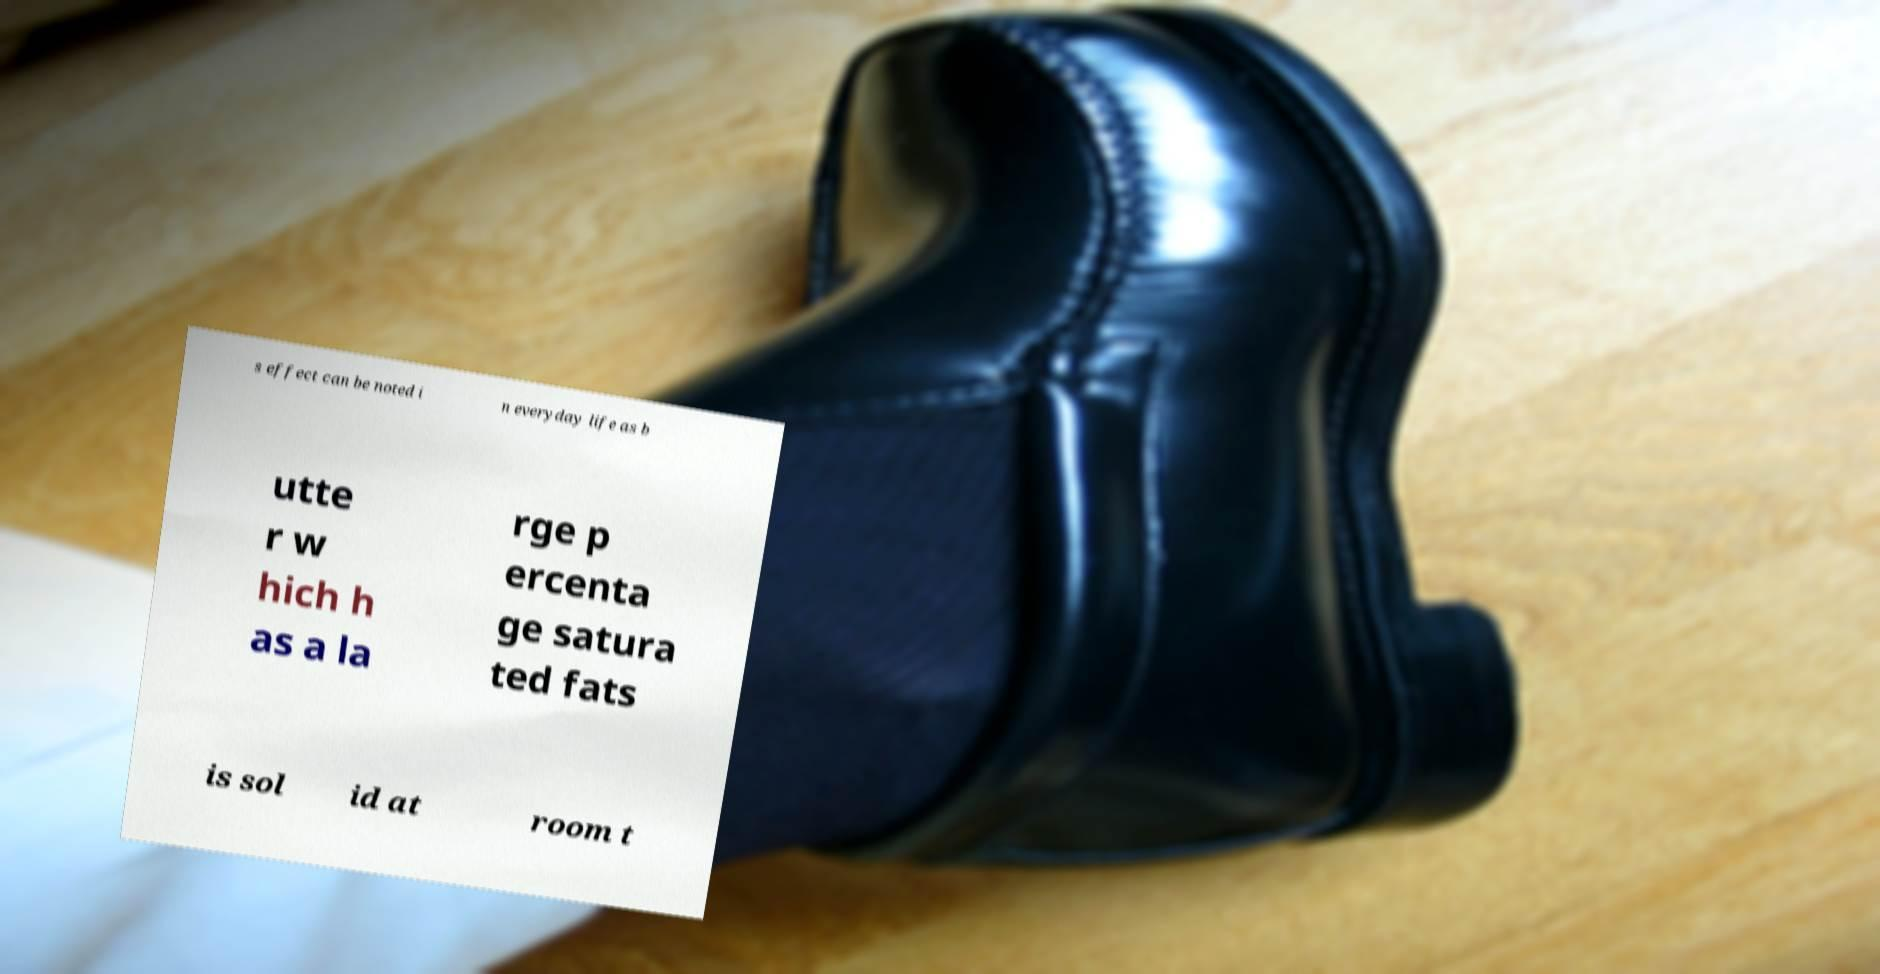Can you read and provide the text displayed in the image?This photo seems to have some interesting text. Can you extract and type it out for me? s effect can be noted i n everyday life as b utte r w hich h as a la rge p ercenta ge satura ted fats is sol id at room t 